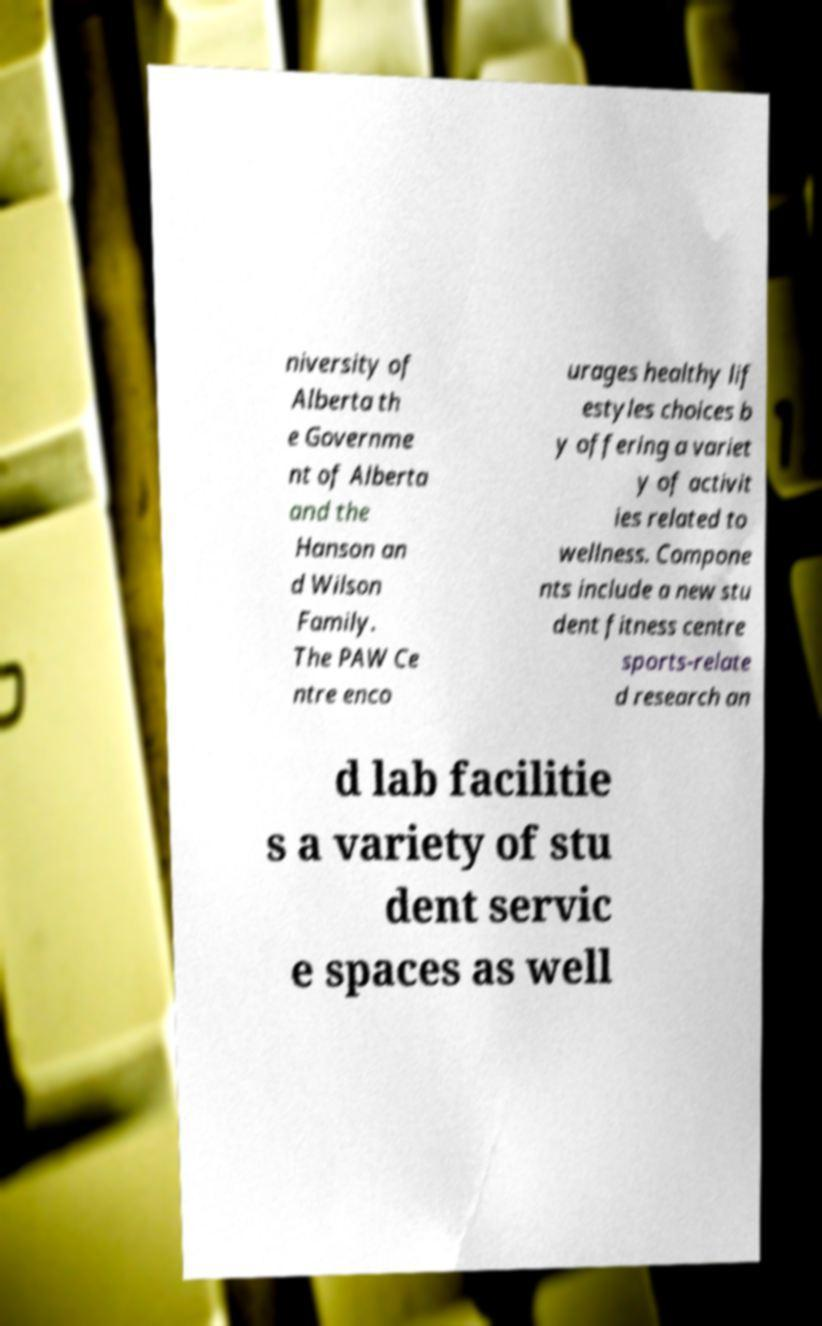Could you extract and type out the text from this image? niversity of Alberta th e Governme nt of Alberta and the Hanson an d Wilson Family. The PAW Ce ntre enco urages healthy lif estyles choices b y offering a variet y of activit ies related to wellness. Compone nts include a new stu dent fitness centre sports-relate d research an d lab facilitie s a variety of stu dent servic e spaces as well 